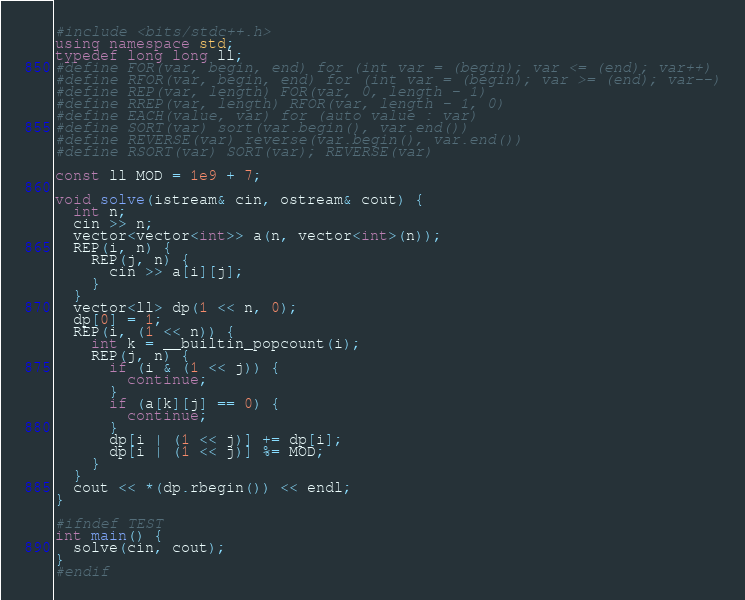<code> <loc_0><loc_0><loc_500><loc_500><_C++_>#include <bits/stdc++.h>
using namespace std;
typedef long long ll;
#define FOR(var, begin, end) for (int var = (begin); var <= (end); var++)
#define RFOR(var, begin, end) for (int var = (begin); var >= (end); var--)
#define REP(var, length) FOR(var, 0, length - 1)
#define RREP(var, length) RFOR(var, length - 1, 0)
#define EACH(value, var) for (auto value : var)
#define SORT(var) sort(var.begin(), var.end())
#define REVERSE(var) reverse(var.begin(), var.end())
#define RSORT(var) SORT(var); REVERSE(var)

const ll MOD = 1e9 + 7;

void solve(istream& cin, ostream& cout) {
  int n;
  cin >> n;
  vector<vector<int>> a(n, vector<int>(n));
  REP(i, n) {
    REP(j, n) {
      cin >> a[i][j];
    }
  }
  vector<ll> dp(1 << n, 0);
  dp[0] = 1;
  REP(i, (1 << n)) {
    int k = __builtin_popcount(i);
    REP(j, n) {
      if (i & (1 << j)) {
        continue;
      }
      if (a[k][j] == 0) {
        continue;
      }
      dp[i | (1 << j)] += dp[i];
      dp[i | (1 << j)] %= MOD;
    }
  }
  cout << *(dp.rbegin()) << endl;
}

#ifndef TEST
int main() {
  solve(cin, cout);
}
#endif
</code> 